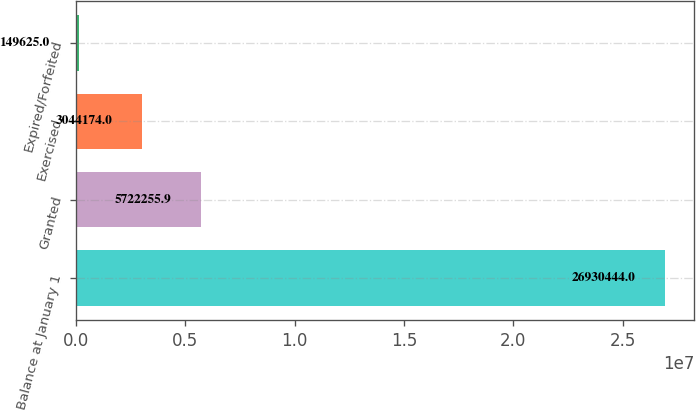Convert chart to OTSL. <chart><loc_0><loc_0><loc_500><loc_500><bar_chart><fcel>Balance at January 1<fcel>Granted<fcel>Exercised<fcel>Expired/Forfeited<nl><fcel>2.69304e+07<fcel>5.72226e+06<fcel>3.04417e+06<fcel>149625<nl></chart> 